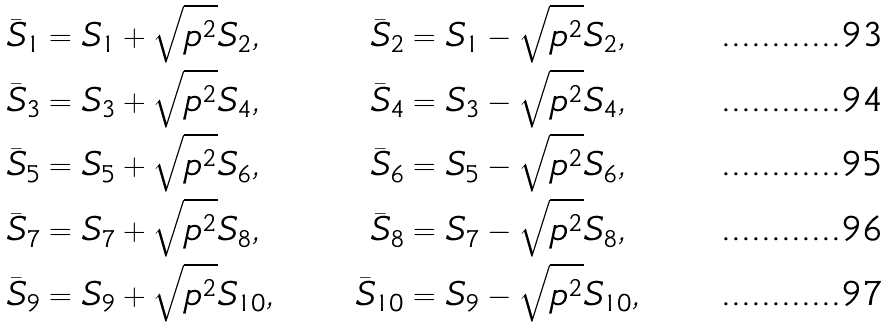<formula> <loc_0><loc_0><loc_500><loc_500>\bar { S } _ { 1 } & = S _ { 1 } + \sqrt { p ^ { 2 } } S _ { 2 } , & \bar { S } _ { 2 } & = S _ { 1 } - \sqrt { p ^ { 2 } } S _ { 2 } , \\ \bar { S } _ { 3 } & = S _ { 3 } + \sqrt { p ^ { 2 } } S _ { 4 } , & \bar { S } _ { 4 } & = S _ { 3 } - \sqrt { p ^ { 2 } } S _ { 4 } , \\ \bar { S } _ { 5 } & = S _ { 5 } + \sqrt { p ^ { 2 } } S _ { 6 } , & \bar { S } _ { 6 } & = S _ { 5 } - \sqrt { p ^ { 2 } } S _ { 6 } , \\ \bar { S } _ { 7 } & = S _ { 7 } + \sqrt { p ^ { 2 } } S _ { 8 } , & \bar { S } _ { 8 } & = S _ { 7 } - \sqrt { p ^ { 2 } } S _ { 8 } , \\ \bar { S } _ { 9 } & = S _ { 9 } + \sqrt { p ^ { 2 } } S _ { 1 0 } , & \bar { S } _ { 1 0 } & = S _ { 9 } - \sqrt { p ^ { 2 } } S _ { 1 0 } ,</formula> 